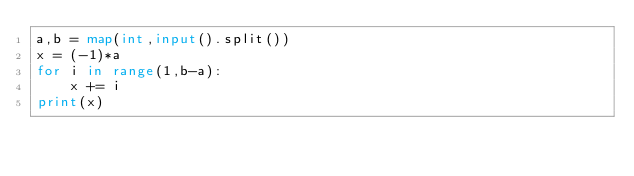<code> <loc_0><loc_0><loc_500><loc_500><_Python_>a,b = map(int,input().split())
x = (-1)*a
for i in range(1,b-a):
    x += i
print(x)
</code> 